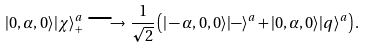<formula> <loc_0><loc_0><loc_500><loc_500>| 0 , \alpha , 0 \rangle | \chi \rangle _ { + } ^ { a } \, \longrightarrow \, \frac { 1 } { \sqrt { 2 } } \left ( | - \alpha , 0 , 0 \rangle | - \rangle ^ { a } + | 0 , \alpha , 0 \rangle | q \rangle ^ { a } \right ) .</formula> 